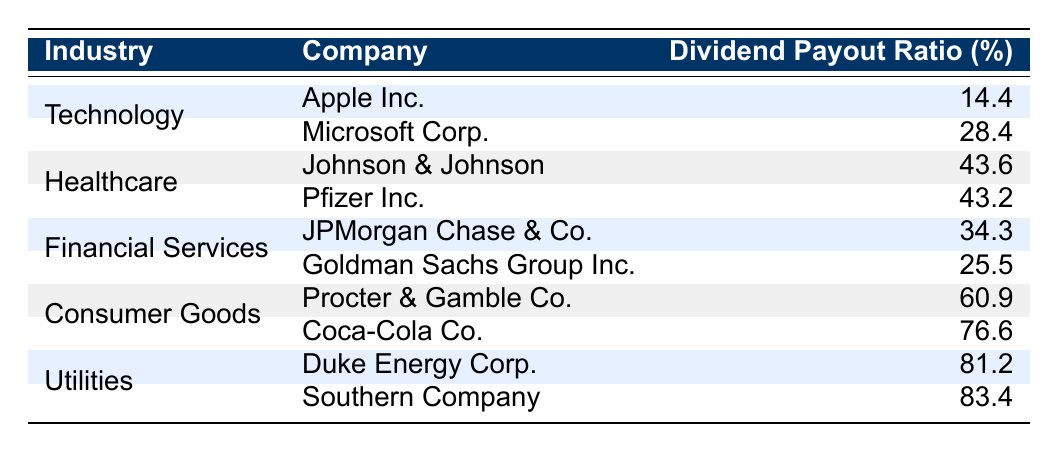What is the highest dividend payout ratio in the Utilities industry? The table shows two companies in the Utilities industry: Duke Energy Corp. with a dividend payout ratio of 81.2 and Southern Company with a dividend payout ratio of 83.4. Since 83.4 is higher, the highest dividend payout ratio is 83.4.
Answer: 83.4 What is the average dividend payout ratio for the Healthcare industry? The table lists Johnson & Johnson (43.6) and Pfizer Inc. (43.2) in the Healthcare industry. To find the average: (43.6 + 43.2) / 2 = 43.4.
Answer: 43.4 Is Apple's dividend payout ratio higher than Microsoft's? According to the table, Apple's dividend payout ratio is 14.4, while Microsoft's is 28.4. Since 14.4 is less than 28.4, the statement is false.
Answer: No What is the total dividend payout ratio for all companies in the Consumer Goods industry? The Consumer Goods industry includes Procter & Gamble Co. (60.9) and Coca-Cola Co. (76.6). Adding these values gives: 60.9 + 76.6 = 137.5.
Answer: 137.5 Which industry has the lowest maximum dividend payout ratio? From the table data, the Technology industry has a maximum dividend payout ratio of 28.4 (Microsoft Corp.), while Healthcare has 43.6, Financial Services has 34.3, Consumer Goods has 76.6, and Utilities has 83.4. So, Technology has the lowest maximum dividend payout ratio.
Answer: Technology What is the difference in dividend payout ratios between the highest and lowest company in the Financial Services industry? From the Financial Services industry, JPMorgan Chase & Co. has a payout ratio of 34.3 and Goldman Sachs Group Inc. has 25.5. Thus, the difference is 34.3 - 25.5 = 8.8.
Answer: 8.8 Are both companies in the Healthcare industry paying out more than 40% of their earnings in dividends? Johnson & Johnson has a payout ratio of 43.6 and Pfizer Inc. has 43.2, both above 40%. Therefore, the answer is yes.
Answer: Yes What company has the highest dividend payout ratio overall? The maximum among all companies listed is Southern Company with a dividend payout ratio of 83.4.
Answer: Southern Company What is the combined dividend payout ratio of the two companies in the Technology industry? The Technology industry includes Apple Inc. (14.4) and Microsoft Corp. (28.4). Their combined payout ratio is 14.4 + 28.4 = 42.8.
Answer: 42.8 